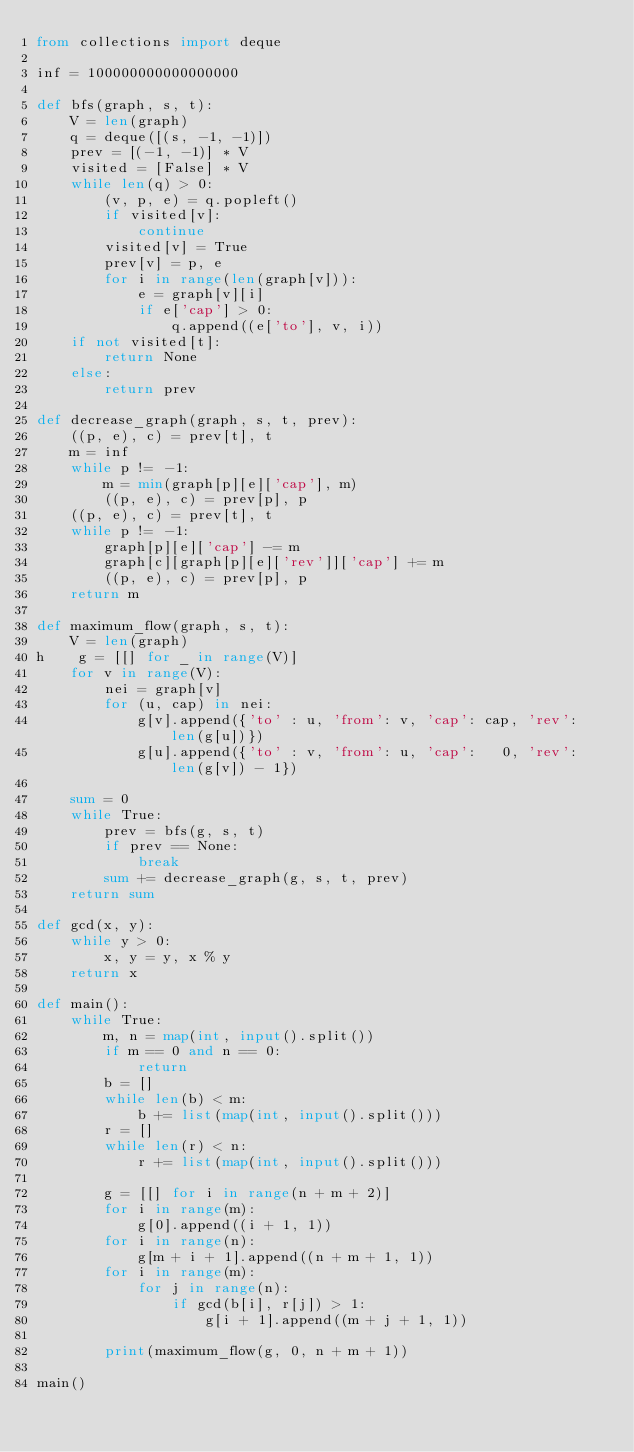Convert code to text. <code><loc_0><loc_0><loc_500><loc_500><_Python_>from collections import deque

inf = 100000000000000000

def bfs(graph, s, t):
    V = len(graph)
    q = deque([(s, -1, -1)])
    prev = [(-1, -1)] * V
    visited = [False] * V
    while len(q) > 0:
        (v, p, e) = q.popleft()
        if visited[v]:
            continue
        visited[v] = True
        prev[v] = p, e
        for i in range(len(graph[v])):
            e = graph[v][i]
            if e['cap'] > 0:
                q.append((e['to'], v, i))
    if not visited[t]:
        return None
    else:
        return prev

def decrease_graph(graph, s, t, prev):
    ((p, e), c) = prev[t], t
    m = inf
    while p != -1:
        m = min(graph[p][e]['cap'], m)
        ((p, e), c) = prev[p], p
    ((p, e), c) = prev[t], t
    while p != -1:
        graph[p][e]['cap'] -= m
        graph[c][graph[p][e]['rev']]['cap'] += m
        ((p, e), c) = prev[p], p
    return m

def maximum_flow(graph, s, t):
    V = len(graph)
h    g = [[] for _ in range(V)]
    for v in range(V):
        nei = graph[v]
        for (u, cap) in nei:
            g[v].append({'to' : u, 'from': v, 'cap': cap, 'rev': len(g[u])})
            g[u].append({'to' : v, 'from': u, 'cap':   0, 'rev': len(g[v]) - 1})
    
    sum = 0
    while True:
        prev = bfs(g, s, t)
        if prev == None:
            break
        sum += decrease_graph(g, s, t, prev)
    return sum

def gcd(x, y):
    while y > 0:
        x, y = y, x % y
    return x

def main():
    while True:
        m, n = map(int, input().split())
        if m == 0 and n == 0:
            return
        b = []
        while len(b) < m:
            b += list(map(int, input().split()))
        r = []
        while len(r) < n:
            r += list(map(int, input().split()))
        
        g = [[] for i in range(n + m + 2)]
        for i in range(m):
            g[0].append((i + 1, 1))
        for i in range(n):
            g[m + i + 1].append((n + m + 1, 1))
        for i in range(m):
            for j in range(n):
                if gcd(b[i], r[j]) > 1:
                    g[i + 1].append((m + j + 1, 1))

        print(maximum_flow(g, 0, n + m + 1))
        
main()</code> 